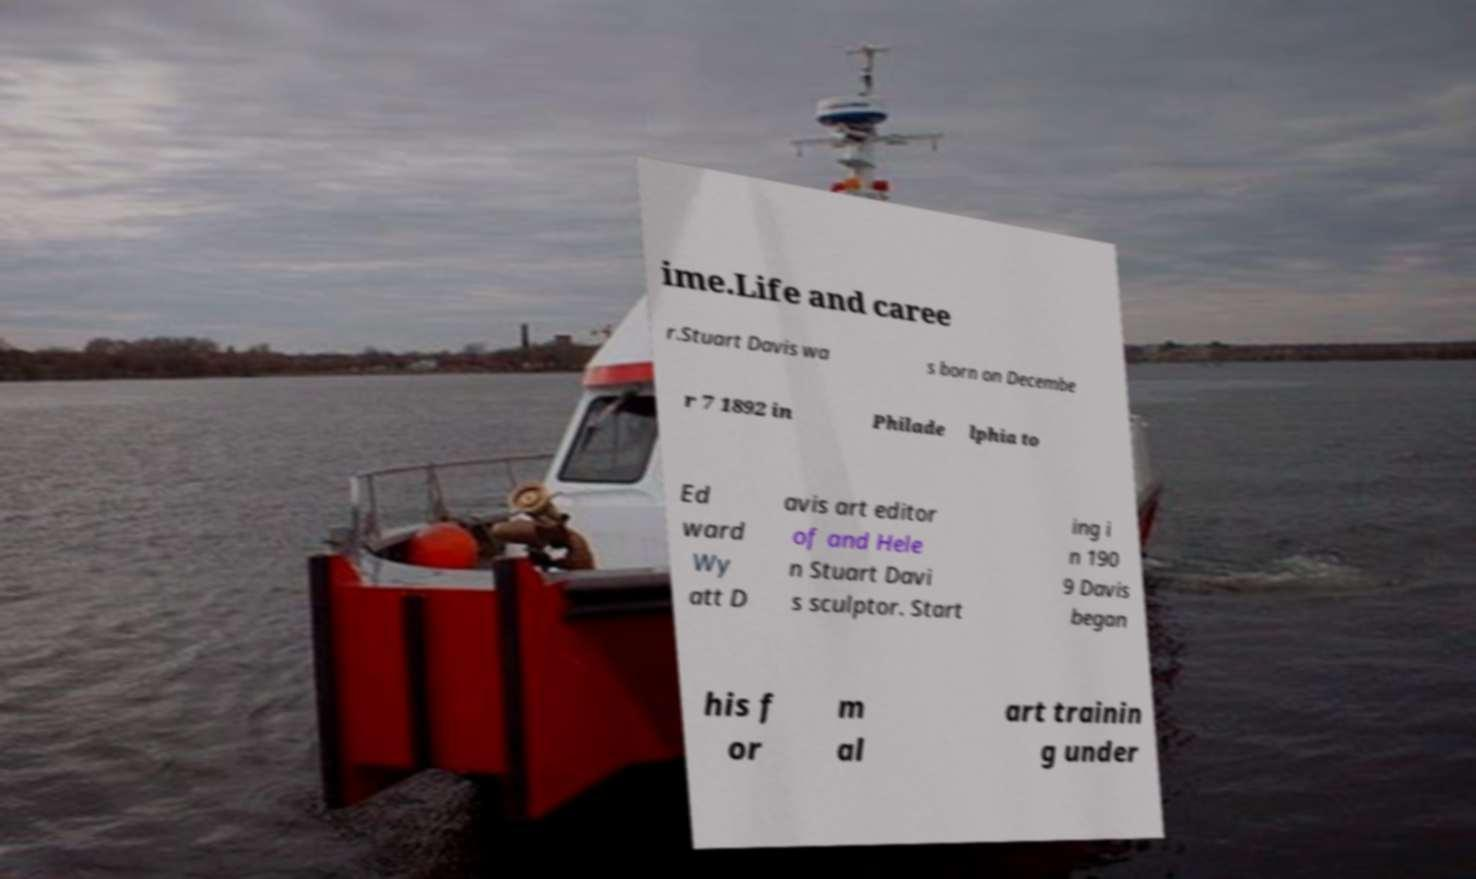For documentation purposes, I need the text within this image transcribed. Could you provide that? ime.Life and caree r.Stuart Davis wa s born on Decembe r 7 1892 in Philade lphia to Ed ward Wy att D avis art editor of and Hele n Stuart Davi s sculptor. Start ing i n 190 9 Davis began his f or m al art trainin g under 